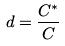<formula> <loc_0><loc_0><loc_500><loc_500>d = \frac { C ^ { * } } { C }</formula> 